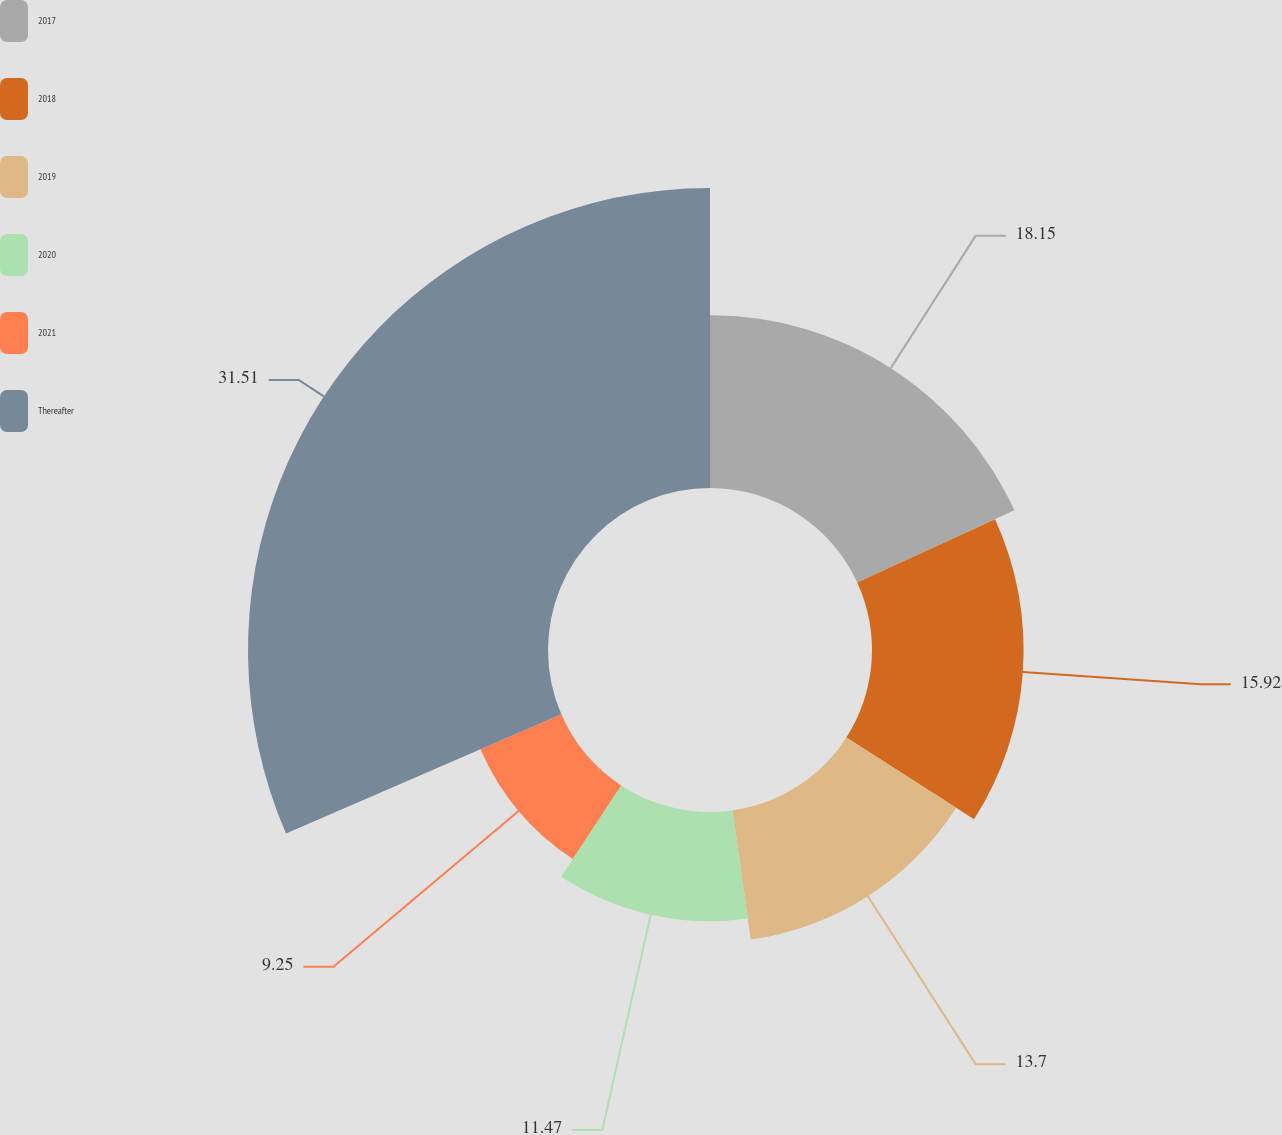Convert chart to OTSL. <chart><loc_0><loc_0><loc_500><loc_500><pie_chart><fcel>2017<fcel>2018<fcel>2019<fcel>2020<fcel>2021<fcel>Thereafter<nl><fcel>18.15%<fcel>15.92%<fcel>13.7%<fcel>11.47%<fcel>9.25%<fcel>31.5%<nl></chart> 